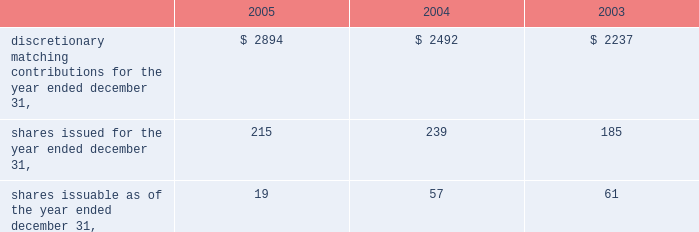Fund .
Employees have the ability to transfer funds from the company stock fund as they choose .
The company declared matching contributions to the vertex 401 ( k ) plan as follows ( in thousands ) : q .
Related party transactions as of december 31 , 2005 and 2004 , the company had an interest-free loan outstanding to an officer in the amount of $ 36000 and $ 97000 , respectively , which was initially advanced in april 2002 .
The loan balance is included in other assets on the consolidated balance sheets .
In 2001 , the company entered into a four year consulting agreement with a director of the company for the provision of part-time consulting services over a period of four years , at the rate of $ 80000 per year commencing in january 2002 and terminating in january 2006 .
Contingencies the company has certain contingent liabilities that arise in the ordinary course of its business activities .
The company accrues contingent liabilities when it is probable that future expenditures will be made and such expenditures can be reasonably estimated .
On december 17 , 2003 , a purported class action , marguerite sacchetti v .
James c .
Blair et al. , was filed in the superior court of the state of california , county of san diego , naming as defendants all of the directors of aurora who approved the merger of aurora and vertex , which closed in july 2001 .
The plaintiffs claim that aurora's directors breached their fiduciary duty to aurora by , among other things , negligently conducting a due diligence examination of vertex by failing to discover alleged problems with vx-745 , a vertex drug candidate that was the subject of a development program which was terminated by vertex in september 2001 .
Vertex has certain indemnity obligations to aurora's directors under the terms of the merger agreement between vertex and aurora , which could result in vertex liability for attorney's fees and costs in connection with this action , as well as for any ultimate judgment that might be awarded .
There is an outstanding directors' and officers' liability policy which may cover a significant portion of any such liability .
The defendants are vigorously defending this suit .
The company believes this suit will be settled without any significant liability to vertex or the former aurora directors .
Guarantees as permitted under massachusetts law , vertex's articles of organization and bylaws provide that the company will indemnify certain of its officers and directors for certain claims asserted against them in connection with their service as an officer or director .
The maximum potential amount of future payments that the company could be required to make under these indemnification provisions is unlimited .
However , the company has purchased certain directors' and officers' liability insurance policies that reduce its monetary exposure and enable it to recover a portion of any future amounts paid .
The company believes the estimated fair value of these indemnification arrangements is minimal .
Discretionary matching contributions for the year ended december 31 , $ 2894 $ 2492 $ 2237 .

What was the change in the the company interest-free loan outstanding to an officer in 2005 and 2004? 
Computations: (97000 - 36000)
Answer: 61000.0. 